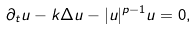<formula> <loc_0><loc_0><loc_500><loc_500>\partial _ { t } u - k \Delta u - | u | ^ { p - 1 } u = 0 ,</formula> 